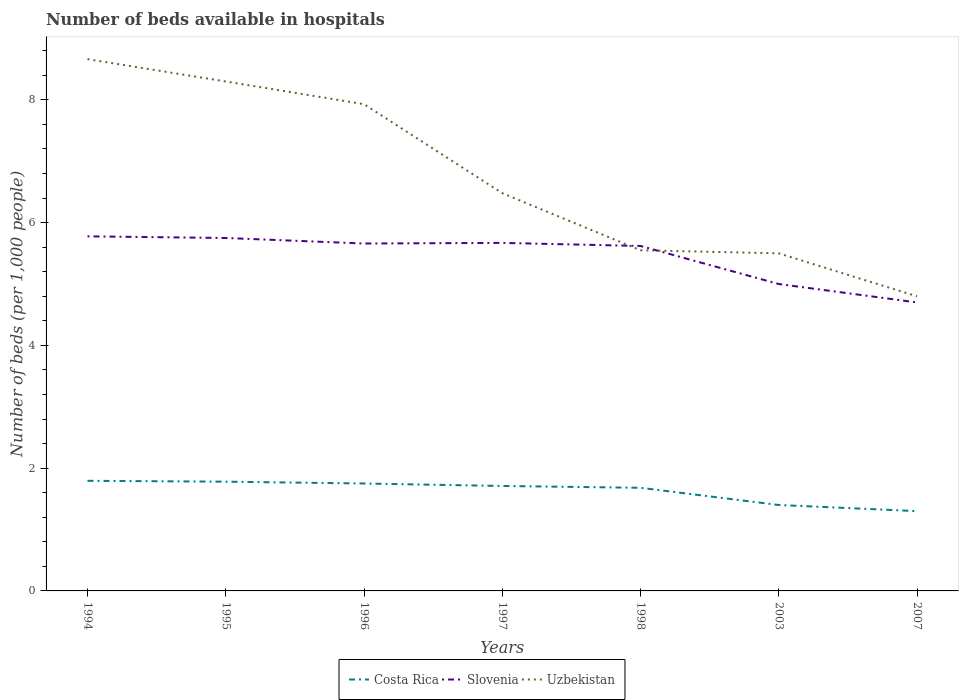Does the line corresponding to Costa Rica intersect with the line corresponding to Uzbekistan?
Ensure brevity in your answer.  No. In which year was the number of beds in the hospiatls of in Slovenia maximum?
Give a very brief answer. 2007. What is the total number of beds in the hospiatls of in Uzbekistan in the graph?
Keep it short and to the point. 0.7. What is the difference between the highest and the second highest number of beds in the hospiatls of in Uzbekistan?
Your response must be concise. 3.86. Is the number of beds in the hospiatls of in Slovenia strictly greater than the number of beds in the hospiatls of in Uzbekistan over the years?
Offer a terse response. No. Are the values on the major ticks of Y-axis written in scientific E-notation?
Ensure brevity in your answer.  No. Where does the legend appear in the graph?
Offer a very short reply. Bottom center. How are the legend labels stacked?
Your answer should be very brief. Horizontal. What is the title of the graph?
Offer a terse response. Number of beds available in hospitals. Does "South Asia" appear as one of the legend labels in the graph?
Your answer should be compact. No. What is the label or title of the Y-axis?
Your answer should be compact. Number of beds (per 1,0 people). What is the Number of beds (per 1,000 people) of Costa Rica in 1994?
Your response must be concise. 1.79. What is the Number of beds (per 1,000 people) in Slovenia in 1994?
Provide a succinct answer. 5.78. What is the Number of beds (per 1,000 people) in Uzbekistan in 1994?
Provide a succinct answer. 8.66. What is the Number of beds (per 1,000 people) of Costa Rica in 1995?
Keep it short and to the point. 1.78. What is the Number of beds (per 1,000 people) in Slovenia in 1995?
Offer a very short reply. 5.75. What is the Number of beds (per 1,000 people) in Uzbekistan in 1995?
Provide a succinct answer. 8.3. What is the Number of beds (per 1,000 people) of Costa Rica in 1996?
Keep it short and to the point. 1.75. What is the Number of beds (per 1,000 people) in Slovenia in 1996?
Ensure brevity in your answer.  5.66. What is the Number of beds (per 1,000 people) in Uzbekistan in 1996?
Provide a short and direct response. 7.93. What is the Number of beds (per 1,000 people) in Costa Rica in 1997?
Offer a terse response. 1.71. What is the Number of beds (per 1,000 people) in Slovenia in 1997?
Your answer should be very brief. 5.67. What is the Number of beds (per 1,000 people) in Uzbekistan in 1997?
Offer a terse response. 6.48. What is the Number of beds (per 1,000 people) of Costa Rica in 1998?
Give a very brief answer. 1.68. What is the Number of beds (per 1,000 people) in Slovenia in 1998?
Your answer should be compact. 5.62. What is the Number of beds (per 1,000 people) in Uzbekistan in 1998?
Provide a short and direct response. 5.55. What is the Number of beds (per 1,000 people) of Costa Rica in 2003?
Keep it short and to the point. 1.4. What is the Number of beds (per 1,000 people) of Uzbekistan in 2003?
Ensure brevity in your answer.  5.5. What is the Number of beds (per 1,000 people) of Slovenia in 2007?
Make the answer very short. 4.7. Across all years, what is the maximum Number of beds (per 1,000 people) of Costa Rica?
Give a very brief answer. 1.79. Across all years, what is the maximum Number of beds (per 1,000 people) of Slovenia?
Keep it short and to the point. 5.78. Across all years, what is the maximum Number of beds (per 1,000 people) in Uzbekistan?
Offer a terse response. 8.66. Across all years, what is the minimum Number of beds (per 1,000 people) in Uzbekistan?
Provide a short and direct response. 4.8. What is the total Number of beds (per 1,000 people) in Costa Rica in the graph?
Your response must be concise. 11.41. What is the total Number of beds (per 1,000 people) in Slovenia in the graph?
Ensure brevity in your answer.  38.18. What is the total Number of beds (per 1,000 people) in Uzbekistan in the graph?
Offer a terse response. 47.22. What is the difference between the Number of beds (per 1,000 people) in Costa Rica in 1994 and that in 1995?
Keep it short and to the point. 0.01. What is the difference between the Number of beds (per 1,000 people) in Slovenia in 1994 and that in 1995?
Provide a short and direct response. 0.03. What is the difference between the Number of beds (per 1,000 people) of Uzbekistan in 1994 and that in 1995?
Provide a short and direct response. 0.36. What is the difference between the Number of beds (per 1,000 people) of Costa Rica in 1994 and that in 1996?
Your answer should be very brief. 0.04. What is the difference between the Number of beds (per 1,000 people) of Slovenia in 1994 and that in 1996?
Provide a short and direct response. 0.12. What is the difference between the Number of beds (per 1,000 people) in Uzbekistan in 1994 and that in 1996?
Your answer should be very brief. 0.73. What is the difference between the Number of beds (per 1,000 people) in Costa Rica in 1994 and that in 1997?
Ensure brevity in your answer.  0.08. What is the difference between the Number of beds (per 1,000 people) of Slovenia in 1994 and that in 1997?
Keep it short and to the point. 0.11. What is the difference between the Number of beds (per 1,000 people) of Uzbekistan in 1994 and that in 1997?
Give a very brief answer. 2.18. What is the difference between the Number of beds (per 1,000 people) in Costa Rica in 1994 and that in 1998?
Offer a terse response. 0.11. What is the difference between the Number of beds (per 1,000 people) of Slovenia in 1994 and that in 1998?
Provide a succinct answer. 0.16. What is the difference between the Number of beds (per 1,000 people) of Uzbekistan in 1994 and that in 1998?
Provide a succinct answer. 3.11. What is the difference between the Number of beds (per 1,000 people) in Costa Rica in 1994 and that in 2003?
Give a very brief answer. 0.39. What is the difference between the Number of beds (per 1,000 people) of Slovenia in 1994 and that in 2003?
Offer a terse response. 0.78. What is the difference between the Number of beds (per 1,000 people) of Uzbekistan in 1994 and that in 2003?
Make the answer very short. 3.16. What is the difference between the Number of beds (per 1,000 people) in Costa Rica in 1994 and that in 2007?
Make the answer very short. 0.49. What is the difference between the Number of beds (per 1,000 people) of Slovenia in 1994 and that in 2007?
Give a very brief answer. 1.08. What is the difference between the Number of beds (per 1,000 people) in Uzbekistan in 1994 and that in 2007?
Give a very brief answer. 3.86. What is the difference between the Number of beds (per 1,000 people) of Slovenia in 1995 and that in 1996?
Make the answer very short. 0.09. What is the difference between the Number of beds (per 1,000 people) in Uzbekistan in 1995 and that in 1996?
Your response must be concise. 0.37. What is the difference between the Number of beds (per 1,000 people) in Costa Rica in 1995 and that in 1997?
Provide a short and direct response. 0.07. What is the difference between the Number of beds (per 1,000 people) of Slovenia in 1995 and that in 1997?
Ensure brevity in your answer.  0.08. What is the difference between the Number of beds (per 1,000 people) in Uzbekistan in 1995 and that in 1997?
Give a very brief answer. 1.82. What is the difference between the Number of beds (per 1,000 people) of Costa Rica in 1995 and that in 1998?
Provide a succinct answer. 0.1. What is the difference between the Number of beds (per 1,000 people) in Slovenia in 1995 and that in 1998?
Your answer should be compact. 0.13. What is the difference between the Number of beds (per 1,000 people) in Uzbekistan in 1995 and that in 1998?
Make the answer very short. 2.75. What is the difference between the Number of beds (per 1,000 people) in Costa Rica in 1995 and that in 2003?
Keep it short and to the point. 0.38. What is the difference between the Number of beds (per 1,000 people) of Slovenia in 1995 and that in 2003?
Your answer should be very brief. 0.75. What is the difference between the Number of beds (per 1,000 people) in Uzbekistan in 1995 and that in 2003?
Offer a terse response. 2.8. What is the difference between the Number of beds (per 1,000 people) in Costa Rica in 1995 and that in 2007?
Offer a terse response. 0.48. What is the difference between the Number of beds (per 1,000 people) in Slovenia in 1995 and that in 2007?
Your answer should be compact. 1.05. What is the difference between the Number of beds (per 1,000 people) of Costa Rica in 1996 and that in 1997?
Make the answer very short. 0.04. What is the difference between the Number of beds (per 1,000 people) in Slovenia in 1996 and that in 1997?
Your answer should be very brief. -0.01. What is the difference between the Number of beds (per 1,000 people) in Uzbekistan in 1996 and that in 1997?
Make the answer very short. 1.45. What is the difference between the Number of beds (per 1,000 people) of Costa Rica in 1996 and that in 1998?
Provide a succinct answer. 0.07. What is the difference between the Number of beds (per 1,000 people) in Slovenia in 1996 and that in 1998?
Provide a short and direct response. 0.04. What is the difference between the Number of beds (per 1,000 people) in Uzbekistan in 1996 and that in 1998?
Your answer should be compact. 2.38. What is the difference between the Number of beds (per 1,000 people) in Slovenia in 1996 and that in 2003?
Offer a very short reply. 0.66. What is the difference between the Number of beds (per 1,000 people) of Uzbekistan in 1996 and that in 2003?
Give a very brief answer. 2.43. What is the difference between the Number of beds (per 1,000 people) of Costa Rica in 1996 and that in 2007?
Provide a succinct answer. 0.45. What is the difference between the Number of beds (per 1,000 people) in Uzbekistan in 1996 and that in 2007?
Keep it short and to the point. 3.13. What is the difference between the Number of beds (per 1,000 people) in Costa Rica in 1997 and that in 1998?
Make the answer very short. 0.03. What is the difference between the Number of beds (per 1,000 people) of Slovenia in 1997 and that in 1998?
Offer a very short reply. 0.05. What is the difference between the Number of beds (per 1,000 people) in Uzbekistan in 1997 and that in 1998?
Keep it short and to the point. 0.93. What is the difference between the Number of beds (per 1,000 people) of Costa Rica in 1997 and that in 2003?
Your answer should be compact. 0.31. What is the difference between the Number of beds (per 1,000 people) of Slovenia in 1997 and that in 2003?
Your answer should be compact. 0.67. What is the difference between the Number of beds (per 1,000 people) in Uzbekistan in 1997 and that in 2003?
Offer a very short reply. 0.98. What is the difference between the Number of beds (per 1,000 people) in Costa Rica in 1997 and that in 2007?
Your response must be concise. 0.41. What is the difference between the Number of beds (per 1,000 people) of Slovenia in 1997 and that in 2007?
Make the answer very short. 0.97. What is the difference between the Number of beds (per 1,000 people) of Uzbekistan in 1997 and that in 2007?
Your answer should be compact. 1.68. What is the difference between the Number of beds (per 1,000 people) in Costa Rica in 1998 and that in 2003?
Make the answer very short. 0.28. What is the difference between the Number of beds (per 1,000 people) of Slovenia in 1998 and that in 2003?
Ensure brevity in your answer.  0.62. What is the difference between the Number of beds (per 1,000 people) in Uzbekistan in 1998 and that in 2003?
Make the answer very short. 0.05. What is the difference between the Number of beds (per 1,000 people) in Costa Rica in 1998 and that in 2007?
Make the answer very short. 0.38. What is the difference between the Number of beds (per 1,000 people) in Slovenia in 1998 and that in 2007?
Your answer should be very brief. 0.92. What is the difference between the Number of beds (per 1,000 people) of Costa Rica in 2003 and that in 2007?
Offer a terse response. 0.1. What is the difference between the Number of beds (per 1,000 people) in Slovenia in 2003 and that in 2007?
Provide a succinct answer. 0.3. What is the difference between the Number of beds (per 1,000 people) of Costa Rica in 1994 and the Number of beds (per 1,000 people) of Slovenia in 1995?
Your answer should be very brief. -3.96. What is the difference between the Number of beds (per 1,000 people) of Costa Rica in 1994 and the Number of beds (per 1,000 people) of Uzbekistan in 1995?
Your answer should be very brief. -6.51. What is the difference between the Number of beds (per 1,000 people) in Slovenia in 1994 and the Number of beds (per 1,000 people) in Uzbekistan in 1995?
Offer a very short reply. -2.52. What is the difference between the Number of beds (per 1,000 people) of Costa Rica in 1994 and the Number of beds (per 1,000 people) of Slovenia in 1996?
Make the answer very short. -3.87. What is the difference between the Number of beds (per 1,000 people) of Costa Rica in 1994 and the Number of beds (per 1,000 people) of Uzbekistan in 1996?
Keep it short and to the point. -6.14. What is the difference between the Number of beds (per 1,000 people) in Slovenia in 1994 and the Number of beds (per 1,000 people) in Uzbekistan in 1996?
Provide a succinct answer. -2.15. What is the difference between the Number of beds (per 1,000 people) in Costa Rica in 1994 and the Number of beds (per 1,000 people) in Slovenia in 1997?
Provide a short and direct response. -3.88. What is the difference between the Number of beds (per 1,000 people) of Costa Rica in 1994 and the Number of beds (per 1,000 people) of Uzbekistan in 1997?
Provide a short and direct response. -4.69. What is the difference between the Number of beds (per 1,000 people) of Slovenia in 1994 and the Number of beds (per 1,000 people) of Uzbekistan in 1997?
Offer a very short reply. -0.7. What is the difference between the Number of beds (per 1,000 people) in Costa Rica in 1994 and the Number of beds (per 1,000 people) in Slovenia in 1998?
Provide a short and direct response. -3.83. What is the difference between the Number of beds (per 1,000 people) in Costa Rica in 1994 and the Number of beds (per 1,000 people) in Uzbekistan in 1998?
Provide a succinct answer. -3.76. What is the difference between the Number of beds (per 1,000 people) in Slovenia in 1994 and the Number of beds (per 1,000 people) in Uzbekistan in 1998?
Make the answer very short. 0.23. What is the difference between the Number of beds (per 1,000 people) in Costa Rica in 1994 and the Number of beds (per 1,000 people) in Slovenia in 2003?
Offer a terse response. -3.21. What is the difference between the Number of beds (per 1,000 people) in Costa Rica in 1994 and the Number of beds (per 1,000 people) in Uzbekistan in 2003?
Offer a terse response. -3.71. What is the difference between the Number of beds (per 1,000 people) of Slovenia in 1994 and the Number of beds (per 1,000 people) of Uzbekistan in 2003?
Your answer should be very brief. 0.28. What is the difference between the Number of beds (per 1,000 people) of Costa Rica in 1994 and the Number of beds (per 1,000 people) of Slovenia in 2007?
Ensure brevity in your answer.  -2.91. What is the difference between the Number of beds (per 1,000 people) in Costa Rica in 1994 and the Number of beds (per 1,000 people) in Uzbekistan in 2007?
Give a very brief answer. -3.01. What is the difference between the Number of beds (per 1,000 people) of Slovenia in 1994 and the Number of beds (per 1,000 people) of Uzbekistan in 2007?
Your answer should be very brief. 0.98. What is the difference between the Number of beds (per 1,000 people) in Costa Rica in 1995 and the Number of beds (per 1,000 people) in Slovenia in 1996?
Provide a succinct answer. -3.88. What is the difference between the Number of beds (per 1,000 people) of Costa Rica in 1995 and the Number of beds (per 1,000 people) of Uzbekistan in 1996?
Offer a very short reply. -6.15. What is the difference between the Number of beds (per 1,000 people) in Slovenia in 1995 and the Number of beds (per 1,000 people) in Uzbekistan in 1996?
Give a very brief answer. -2.18. What is the difference between the Number of beds (per 1,000 people) of Costa Rica in 1995 and the Number of beds (per 1,000 people) of Slovenia in 1997?
Make the answer very short. -3.89. What is the difference between the Number of beds (per 1,000 people) of Costa Rica in 1995 and the Number of beds (per 1,000 people) of Uzbekistan in 1997?
Keep it short and to the point. -4.7. What is the difference between the Number of beds (per 1,000 people) of Slovenia in 1995 and the Number of beds (per 1,000 people) of Uzbekistan in 1997?
Give a very brief answer. -0.73. What is the difference between the Number of beds (per 1,000 people) in Costa Rica in 1995 and the Number of beds (per 1,000 people) in Slovenia in 1998?
Offer a terse response. -3.84. What is the difference between the Number of beds (per 1,000 people) of Costa Rica in 1995 and the Number of beds (per 1,000 people) of Uzbekistan in 1998?
Keep it short and to the point. -3.77. What is the difference between the Number of beds (per 1,000 people) in Slovenia in 1995 and the Number of beds (per 1,000 people) in Uzbekistan in 1998?
Offer a very short reply. 0.2. What is the difference between the Number of beds (per 1,000 people) of Costa Rica in 1995 and the Number of beds (per 1,000 people) of Slovenia in 2003?
Offer a terse response. -3.22. What is the difference between the Number of beds (per 1,000 people) of Costa Rica in 1995 and the Number of beds (per 1,000 people) of Uzbekistan in 2003?
Give a very brief answer. -3.72. What is the difference between the Number of beds (per 1,000 people) in Costa Rica in 1995 and the Number of beds (per 1,000 people) in Slovenia in 2007?
Offer a very short reply. -2.92. What is the difference between the Number of beds (per 1,000 people) in Costa Rica in 1995 and the Number of beds (per 1,000 people) in Uzbekistan in 2007?
Offer a very short reply. -3.02. What is the difference between the Number of beds (per 1,000 people) of Costa Rica in 1996 and the Number of beds (per 1,000 people) of Slovenia in 1997?
Give a very brief answer. -3.92. What is the difference between the Number of beds (per 1,000 people) of Costa Rica in 1996 and the Number of beds (per 1,000 people) of Uzbekistan in 1997?
Provide a short and direct response. -4.73. What is the difference between the Number of beds (per 1,000 people) in Slovenia in 1996 and the Number of beds (per 1,000 people) in Uzbekistan in 1997?
Offer a very short reply. -0.82. What is the difference between the Number of beds (per 1,000 people) of Costa Rica in 1996 and the Number of beds (per 1,000 people) of Slovenia in 1998?
Offer a very short reply. -3.87. What is the difference between the Number of beds (per 1,000 people) of Costa Rica in 1996 and the Number of beds (per 1,000 people) of Uzbekistan in 1998?
Your answer should be compact. -3.8. What is the difference between the Number of beds (per 1,000 people) of Slovenia in 1996 and the Number of beds (per 1,000 people) of Uzbekistan in 1998?
Keep it short and to the point. 0.11. What is the difference between the Number of beds (per 1,000 people) in Costa Rica in 1996 and the Number of beds (per 1,000 people) in Slovenia in 2003?
Your response must be concise. -3.25. What is the difference between the Number of beds (per 1,000 people) of Costa Rica in 1996 and the Number of beds (per 1,000 people) of Uzbekistan in 2003?
Give a very brief answer. -3.75. What is the difference between the Number of beds (per 1,000 people) of Slovenia in 1996 and the Number of beds (per 1,000 people) of Uzbekistan in 2003?
Your answer should be compact. 0.16. What is the difference between the Number of beds (per 1,000 people) in Costa Rica in 1996 and the Number of beds (per 1,000 people) in Slovenia in 2007?
Your answer should be compact. -2.95. What is the difference between the Number of beds (per 1,000 people) of Costa Rica in 1996 and the Number of beds (per 1,000 people) of Uzbekistan in 2007?
Provide a succinct answer. -3.05. What is the difference between the Number of beds (per 1,000 people) of Slovenia in 1996 and the Number of beds (per 1,000 people) of Uzbekistan in 2007?
Your response must be concise. 0.86. What is the difference between the Number of beds (per 1,000 people) of Costa Rica in 1997 and the Number of beds (per 1,000 people) of Slovenia in 1998?
Ensure brevity in your answer.  -3.91. What is the difference between the Number of beds (per 1,000 people) of Costa Rica in 1997 and the Number of beds (per 1,000 people) of Uzbekistan in 1998?
Provide a short and direct response. -3.84. What is the difference between the Number of beds (per 1,000 people) in Slovenia in 1997 and the Number of beds (per 1,000 people) in Uzbekistan in 1998?
Ensure brevity in your answer.  0.12. What is the difference between the Number of beds (per 1,000 people) of Costa Rica in 1997 and the Number of beds (per 1,000 people) of Slovenia in 2003?
Give a very brief answer. -3.29. What is the difference between the Number of beds (per 1,000 people) in Costa Rica in 1997 and the Number of beds (per 1,000 people) in Uzbekistan in 2003?
Your answer should be compact. -3.79. What is the difference between the Number of beds (per 1,000 people) in Slovenia in 1997 and the Number of beds (per 1,000 people) in Uzbekistan in 2003?
Keep it short and to the point. 0.17. What is the difference between the Number of beds (per 1,000 people) in Costa Rica in 1997 and the Number of beds (per 1,000 people) in Slovenia in 2007?
Offer a very short reply. -2.99. What is the difference between the Number of beds (per 1,000 people) of Costa Rica in 1997 and the Number of beds (per 1,000 people) of Uzbekistan in 2007?
Your answer should be compact. -3.09. What is the difference between the Number of beds (per 1,000 people) of Slovenia in 1997 and the Number of beds (per 1,000 people) of Uzbekistan in 2007?
Offer a very short reply. 0.87. What is the difference between the Number of beds (per 1,000 people) of Costa Rica in 1998 and the Number of beds (per 1,000 people) of Slovenia in 2003?
Make the answer very short. -3.32. What is the difference between the Number of beds (per 1,000 people) in Costa Rica in 1998 and the Number of beds (per 1,000 people) in Uzbekistan in 2003?
Your answer should be compact. -3.82. What is the difference between the Number of beds (per 1,000 people) in Slovenia in 1998 and the Number of beds (per 1,000 people) in Uzbekistan in 2003?
Offer a very short reply. 0.12. What is the difference between the Number of beds (per 1,000 people) of Costa Rica in 1998 and the Number of beds (per 1,000 people) of Slovenia in 2007?
Give a very brief answer. -3.02. What is the difference between the Number of beds (per 1,000 people) of Costa Rica in 1998 and the Number of beds (per 1,000 people) of Uzbekistan in 2007?
Offer a very short reply. -3.12. What is the difference between the Number of beds (per 1,000 people) in Slovenia in 1998 and the Number of beds (per 1,000 people) in Uzbekistan in 2007?
Your answer should be compact. 0.82. What is the difference between the Number of beds (per 1,000 people) of Costa Rica in 2003 and the Number of beds (per 1,000 people) of Slovenia in 2007?
Ensure brevity in your answer.  -3.3. What is the average Number of beds (per 1,000 people) in Costa Rica per year?
Your answer should be compact. 1.63. What is the average Number of beds (per 1,000 people) of Slovenia per year?
Your response must be concise. 5.45. What is the average Number of beds (per 1,000 people) of Uzbekistan per year?
Provide a short and direct response. 6.75. In the year 1994, what is the difference between the Number of beds (per 1,000 people) of Costa Rica and Number of beds (per 1,000 people) of Slovenia?
Provide a succinct answer. -3.98. In the year 1994, what is the difference between the Number of beds (per 1,000 people) in Costa Rica and Number of beds (per 1,000 people) in Uzbekistan?
Give a very brief answer. -6.87. In the year 1994, what is the difference between the Number of beds (per 1,000 people) of Slovenia and Number of beds (per 1,000 people) of Uzbekistan?
Give a very brief answer. -2.89. In the year 1995, what is the difference between the Number of beds (per 1,000 people) of Costa Rica and Number of beds (per 1,000 people) of Slovenia?
Your response must be concise. -3.97. In the year 1995, what is the difference between the Number of beds (per 1,000 people) in Costa Rica and Number of beds (per 1,000 people) in Uzbekistan?
Keep it short and to the point. -6.52. In the year 1995, what is the difference between the Number of beds (per 1,000 people) of Slovenia and Number of beds (per 1,000 people) of Uzbekistan?
Offer a terse response. -2.55. In the year 1996, what is the difference between the Number of beds (per 1,000 people) of Costa Rica and Number of beds (per 1,000 people) of Slovenia?
Ensure brevity in your answer.  -3.91. In the year 1996, what is the difference between the Number of beds (per 1,000 people) of Costa Rica and Number of beds (per 1,000 people) of Uzbekistan?
Your answer should be compact. -6.18. In the year 1996, what is the difference between the Number of beds (per 1,000 people) in Slovenia and Number of beds (per 1,000 people) in Uzbekistan?
Keep it short and to the point. -2.27. In the year 1997, what is the difference between the Number of beds (per 1,000 people) in Costa Rica and Number of beds (per 1,000 people) in Slovenia?
Give a very brief answer. -3.96. In the year 1997, what is the difference between the Number of beds (per 1,000 people) in Costa Rica and Number of beds (per 1,000 people) in Uzbekistan?
Provide a succinct answer. -4.77. In the year 1997, what is the difference between the Number of beds (per 1,000 people) in Slovenia and Number of beds (per 1,000 people) in Uzbekistan?
Your response must be concise. -0.81. In the year 1998, what is the difference between the Number of beds (per 1,000 people) in Costa Rica and Number of beds (per 1,000 people) in Slovenia?
Offer a very short reply. -3.94. In the year 1998, what is the difference between the Number of beds (per 1,000 people) in Costa Rica and Number of beds (per 1,000 people) in Uzbekistan?
Ensure brevity in your answer.  -3.87. In the year 1998, what is the difference between the Number of beds (per 1,000 people) in Slovenia and Number of beds (per 1,000 people) in Uzbekistan?
Provide a succinct answer. 0.07. In the year 2003, what is the difference between the Number of beds (per 1,000 people) in Costa Rica and Number of beds (per 1,000 people) in Slovenia?
Your response must be concise. -3.6. In the year 2003, what is the difference between the Number of beds (per 1,000 people) in Costa Rica and Number of beds (per 1,000 people) in Uzbekistan?
Your answer should be very brief. -4.1. In the year 2003, what is the difference between the Number of beds (per 1,000 people) in Slovenia and Number of beds (per 1,000 people) in Uzbekistan?
Ensure brevity in your answer.  -0.5. In the year 2007, what is the difference between the Number of beds (per 1,000 people) of Costa Rica and Number of beds (per 1,000 people) of Uzbekistan?
Offer a very short reply. -3.5. What is the ratio of the Number of beds (per 1,000 people) of Costa Rica in 1994 to that in 1995?
Provide a succinct answer. 1.01. What is the ratio of the Number of beds (per 1,000 people) of Slovenia in 1994 to that in 1995?
Ensure brevity in your answer.  1. What is the ratio of the Number of beds (per 1,000 people) of Uzbekistan in 1994 to that in 1995?
Make the answer very short. 1.04. What is the ratio of the Number of beds (per 1,000 people) in Costa Rica in 1994 to that in 1996?
Your response must be concise. 1.03. What is the ratio of the Number of beds (per 1,000 people) in Slovenia in 1994 to that in 1996?
Your response must be concise. 1.02. What is the ratio of the Number of beds (per 1,000 people) of Uzbekistan in 1994 to that in 1996?
Your response must be concise. 1.09. What is the ratio of the Number of beds (per 1,000 people) of Costa Rica in 1994 to that in 1997?
Make the answer very short. 1.05. What is the ratio of the Number of beds (per 1,000 people) of Slovenia in 1994 to that in 1997?
Provide a succinct answer. 1.02. What is the ratio of the Number of beds (per 1,000 people) of Uzbekistan in 1994 to that in 1997?
Give a very brief answer. 1.34. What is the ratio of the Number of beds (per 1,000 people) of Costa Rica in 1994 to that in 1998?
Offer a terse response. 1.07. What is the ratio of the Number of beds (per 1,000 people) in Slovenia in 1994 to that in 1998?
Offer a terse response. 1.03. What is the ratio of the Number of beds (per 1,000 people) of Uzbekistan in 1994 to that in 1998?
Your response must be concise. 1.56. What is the ratio of the Number of beds (per 1,000 people) of Costa Rica in 1994 to that in 2003?
Make the answer very short. 1.28. What is the ratio of the Number of beds (per 1,000 people) in Slovenia in 1994 to that in 2003?
Keep it short and to the point. 1.16. What is the ratio of the Number of beds (per 1,000 people) of Uzbekistan in 1994 to that in 2003?
Offer a terse response. 1.58. What is the ratio of the Number of beds (per 1,000 people) in Costa Rica in 1994 to that in 2007?
Ensure brevity in your answer.  1.38. What is the ratio of the Number of beds (per 1,000 people) of Slovenia in 1994 to that in 2007?
Your answer should be compact. 1.23. What is the ratio of the Number of beds (per 1,000 people) of Uzbekistan in 1994 to that in 2007?
Your answer should be compact. 1.8. What is the ratio of the Number of beds (per 1,000 people) of Costa Rica in 1995 to that in 1996?
Your response must be concise. 1.02. What is the ratio of the Number of beds (per 1,000 people) in Slovenia in 1995 to that in 1996?
Offer a very short reply. 1.02. What is the ratio of the Number of beds (per 1,000 people) in Uzbekistan in 1995 to that in 1996?
Your answer should be very brief. 1.05. What is the ratio of the Number of beds (per 1,000 people) of Costa Rica in 1995 to that in 1997?
Your response must be concise. 1.04. What is the ratio of the Number of beds (per 1,000 people) of Slovenia in 1995 to that in 1997?
Offer a terse response. 1.01. What is the ratio of the Number of beds (per 1,000 people) in Uzbekistan in 1995 to that in 1997?
Provide a short and direct response. 1.28. What is the ratio of the Number of beds (per 1,000 people) of Costa Rica in 1995 to that in 1998?
Offer a terse response. 1.06. What is the ratio of the Number of beds (per 1,000 people) of Slovenia in 1995 to that in 1998?
Provide a succinct answer. 1.02. What is the ratio of the Number of beds (per 1,000 people) of Uzbekistan in 1995 to that in 1998?
Keep it short and to the point. 1.5. What is the ratio of the Number of beds (per 1,000 people) in Costa Rica in 1995 to that in 2003?
Your answer should be compact. 1.27. What is the ratio of the Number of beds (per 1,000 people) of Slovenia in 1995 to that in 2003?
Give a very brief answer. 1.15. What is the ratio of the Number of beds (per 1,000 people) of Uzbekistan in 1995 to that in 2003?
Offer a very short reply. 1.51. What is the ratio of the Number of beds (per 1,000 people) in Costa Rica in 1995 to that in 2007?
Keep it short and to the point. 1.37. What is the ratio of the Number of beds (per 1,000 people) in Slovenia in 1995 to that in 2007?
Your response must be concise. 1.22. What is the ratio of the Number of beds (per 1,000 people) in Uzbekistan in 1995 to that in 2007?
Ensure brevity in your answer.  1.73. What is the ratio of the Number of beds (per 1,000 people) in Costa Rica in 1996 to that in 1997?
Your answer should be very brief. 1.02. What is the ratio of the Number of beds (per 1,000 people) of Slovenia in 1996 to that in 1997?
Keep it short and to the point. 1. What is the ratio of the Number of beds (per 1,000 people) in Uzbekistan in 1996 to that in 1997?
Give a very brief answer. 1.22. What is the ratio of the Number of beds (per 1,000 people) of Costa Rica in 1996 to that in 1998?
Your response must be concise. 1.04. What is the ratio of the Number of beds (per 1,000 people) of Slovenia in 1996 to that in 1998?
Provide a short and direct response. 1.01. What is the ratio of the Number of beds (per 1,000 people) of Uzbekistan in 1996 to that in 1998?
Your answer should be compact. 1.43. What is the ratio of the Number of beds (per 1,000 people) of Slovenia in 1996 to that in 2003?
Ensure brevity in your answer.  1.13. What is the ratio of the Number of beds (per 1,000 people) in Uzbekistan in 1996 to that in 2003?
Keep it short and to the point. 1.44. What is the ratio of the Number of beds (per 1,000 people) of Costa Rica in 1996 to that in 2007?
Keep it short and to the point. 1.35. What is the ratio of the Number of beds (per 1,000 people) in Slovenia in 1996 to that in 2007?
Ensure brevity in your answer.  1.2. What is the ratio of the Number of beds (per 1,000 people) in Uzbekistan in 1996 to that in 2007?
Your answer should be very brief. 1.65. What is the ratio of the Number of beds (per 1,000 people) of Costa Rica in 1997 to that in 1998?
Your answer should be very brief. 1.02. What is the ratio of the Number of beds (per 1,000 people) of Slovenia in 1997 to that in 1998?
Offer a very short reply. 1.01. What is the ratio of the Number of beds (per 1,000 people) of Uzbekistan in 1997 to that in 1998?
Ensure brevity in your answer.  1.17. What is the ratio of the Number of beds (per 1,000 people) of Costa Rica in 1997 to that in 2003?
Keep it short and to the point. 1.22. What is the ratio of the Number of beds (per 1,000 people) in Slovenia in 1997 to that in 2003?
Provide a short and direct response. 1.13. What is the ratio of the Number of beds (per 1,000 people) of Uzbekistan in 1997 to that in 2003?
Make the answer very short. 1.18. What is the ratio of the Number of beds (per 1,000 people) in Costa Rica in 1997 to that in 2007?
Offer a very short reply. 1.32. What is the ratio of the Number of beds (per 1,000 people) in Slovenia in 1997 to that in 2007?
Make the answer very short. 1.21. What is the ratio of the Number of beds (per 1,000 people) of Uzbekistan in 1997 to that in 2007?
Keep it short and to the point. 1.35. What is the ratio of the Number of beds (per 1,000 people) in Slovenia in 1998 to that in 2003?
Your response must be concise. 1.12. What is the ratio of the Number of beds (per 1,000 people) of Uzbekistan in 1998 to that in 2003?
Provide a short and direct response. 1.01. What is the ratio of the Number of beds (per 1,000 people) in Costa Rica in 1998 to that in 2007?
Your answer should be compact. 1.29. What is the ratio of the Number of beds (per 1,000 people) in Slovenia in 1998 to that in 2007?
Provide a short and direct response. 1.2. What is the ratio of the Number of beds (per 1,000 people) in Uzbekistan in 1998 to that in 2007?
Provide a short and direct response. 1.16. What is the ratio of the Number of beds (per 1,000 people) in Costa Rica in 2003 to that in 2007?
Your answer should be compact. 1.08. What is the ratio of the Number of beds (per 1,000 people) in Slovenia in 2003 to that in 2007?
Your answer should be very brief. 1.06. What is the ratio of the Number of beds (per 1,000 people) in Uzbekistan in 2003 to that in 2007?
Make the answer very short. 1.15. What is the difference between the highest and the second highest Number of beds (per 1,000 people) of Costa Rica?
Give a very brief answer. 0.01. What is the difference between the highest and the second highest Number of beds (per 1,000 people) of Slovenia?
Your answer should be compact. 0.03. What is the difference between the highest and the second highest Number of beds (per 1,000 people) in Uzbekistan?
Your response must be concise. 0.36. What is the difference between the highest and the lowest Number of beds (per 1,000 people) of Costa Rica?
Your answer should be very brief. 0.49. What is the difference between the highest and the lowest Number of beds (per 1,000 people) of Slovenia?
Give a very brief answer. 1.08. What is the difference between the highest and the lowest Number of beds (per 1,000 people) in Uzbekistan?
Provide a short and direct response. 3.86. 